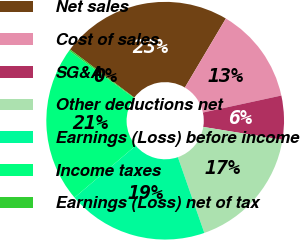Convert chart to OTSL. <chart><loc_0><loc_0><loc_500><loc_500><pie_chart><fcel>Net sales<fcel>Cost of sales<fcel>SG&A<fcel>Other deductions net<fcel>Earnings (Loss) before income<fcel>Income taxes<fcel>Earnings (Loss) net of tax<nl><fcel>23.29%<fcel>13.07%<fcel>5.97%<fcel>17.08%<fcel>19.15%<fcel>21.22%<fcel>0.2%<nl></chart> 